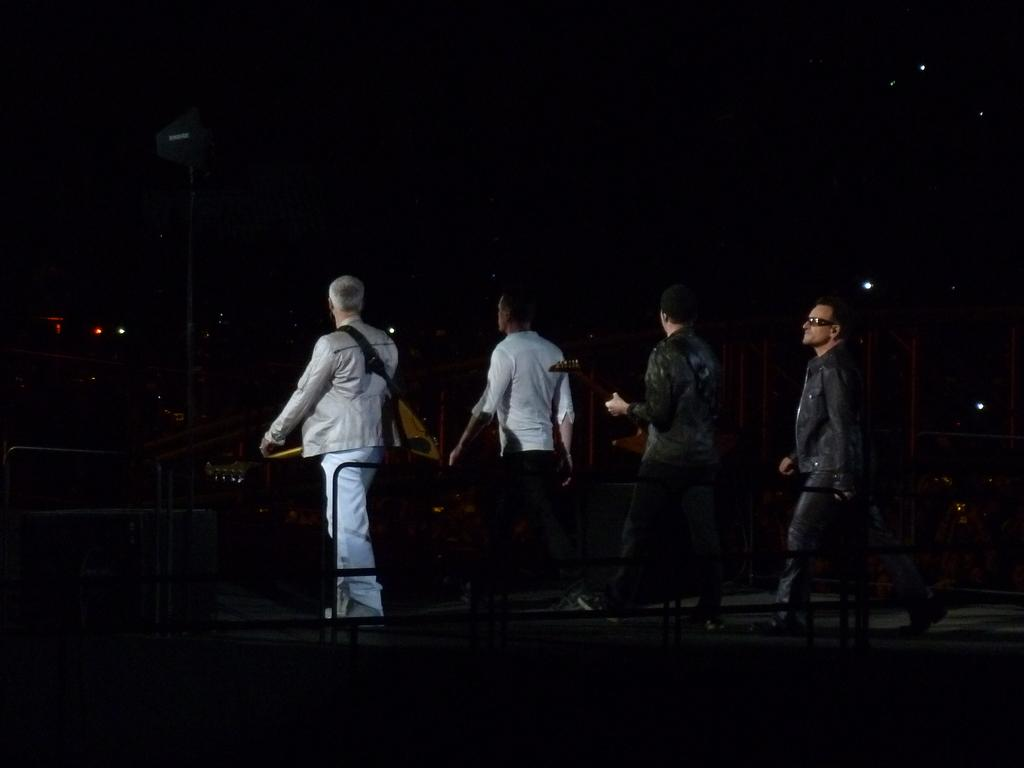What are the people in the image doing? The people in the image are walking. Where are the people walking in the image? The people are walking in the center of the image. What can be seen in front of the image? There is a railing in front of the image. What is the manager's role in the image? There is no mention of a manager in the image, so we cannot determine their role. 